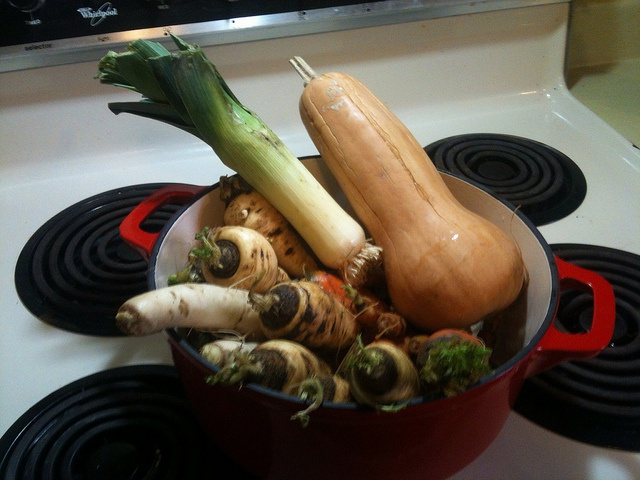Describe the objects in this image and their specific colors. I can see oven in black, darkgray, gray, and maroon tones, carrot in black, darkgreen, and maroon tones, carrot in black, brown, maroon, and gray tones, and carrot in black, maroon, olive, and brown tones in this image. 